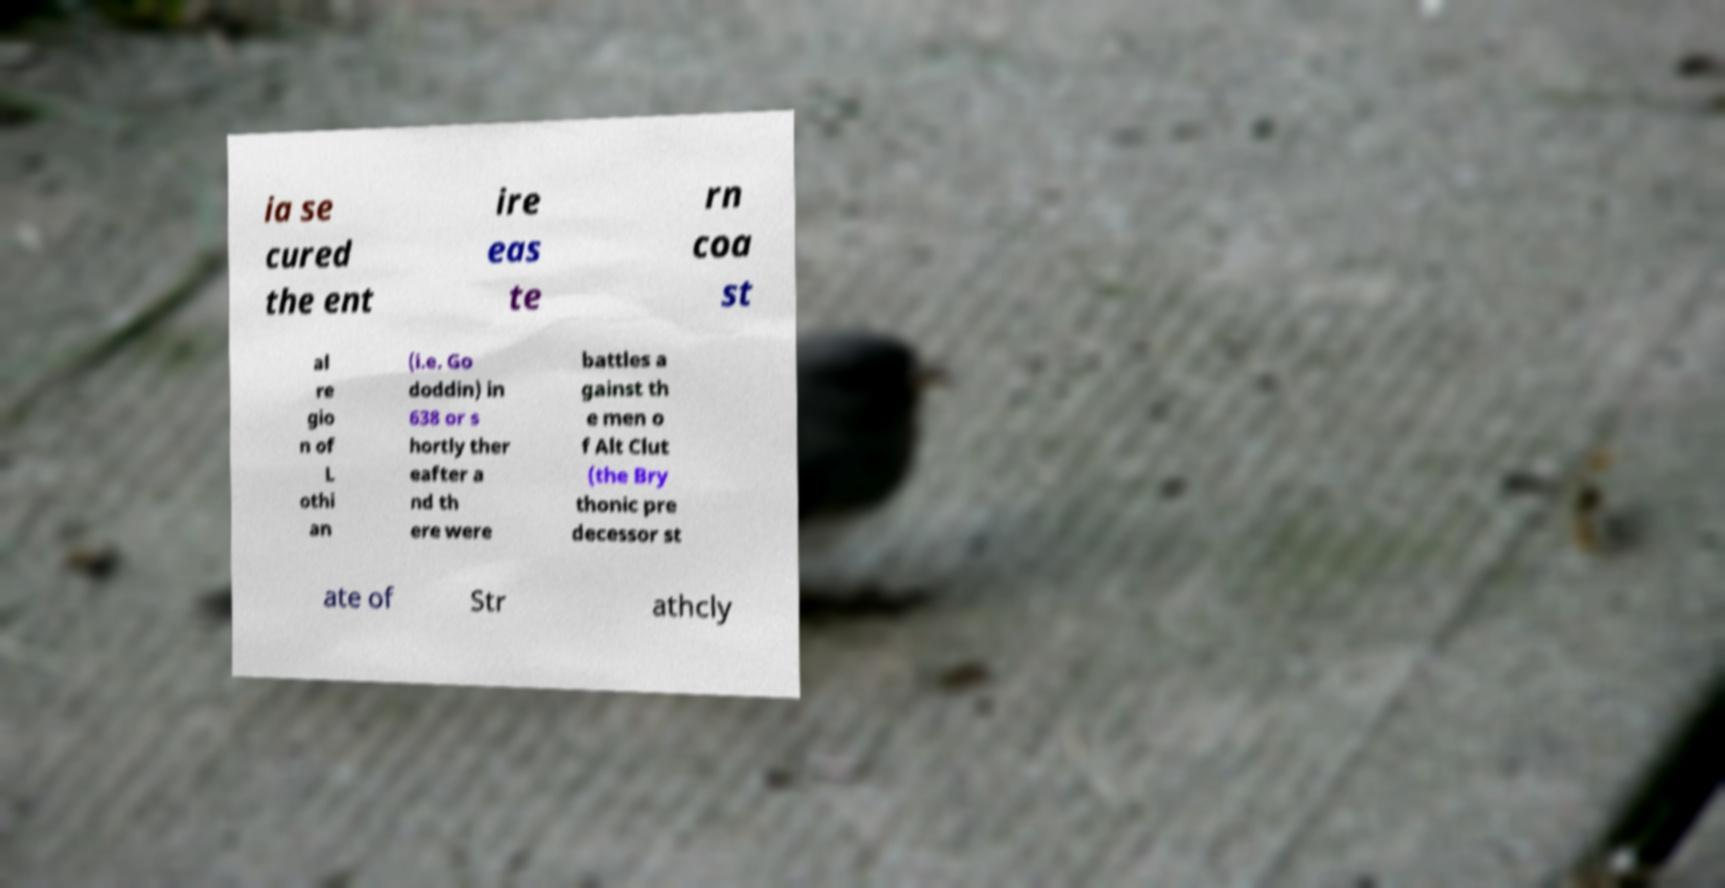I need the written content from this picture converted into text. Can you do that? ia se cured the ent ire eas te rn coa st al re gio n of L othi an (i.e. Go doddin) in 638 or s hortly ther eafter a nd th ere were battles a gainst th e men o f Alt Clut (the Bry thonic pre decessor st ate of Str athcly 